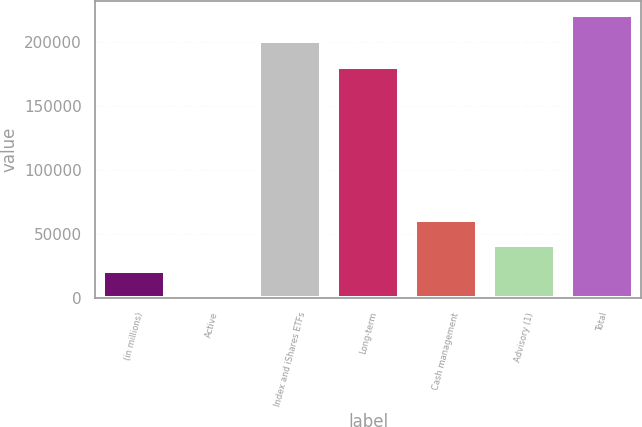<chart> <loc_0><loc_0><loc_500><loc_500><bar_chart><fcel>(in millions)<fcel>Active<fcel>Index and iShares ETFs<fcel>Long-term<fcel>Cash management<fcel>Advisory (1)<fcel>Total<nl><fcel>20915.7<fcel>774<fcel>200706<fcel>180564<fcel>61199.1<fcel>41057.4<fcel>220847<nl></chart> 